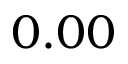Convert formula to latex. <formula><loc_0><loc_0><loc_500><loc_500>0 . 0 0</formula> 